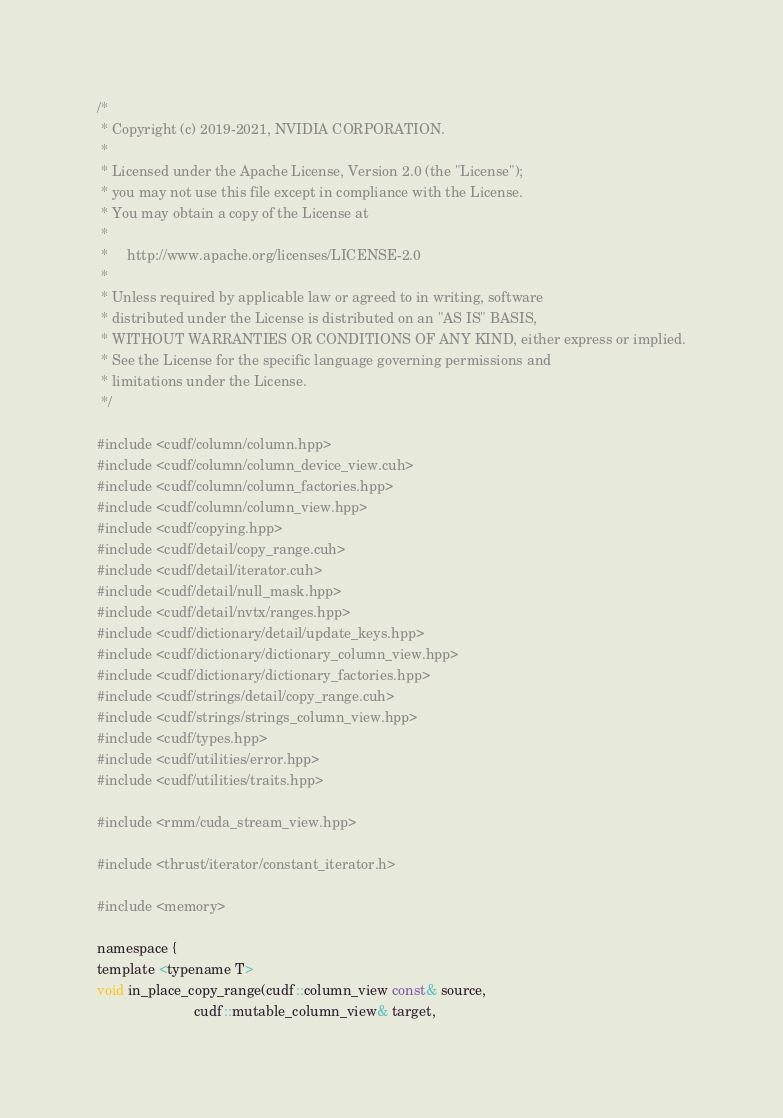Convert code to text. <code><loc_0><loc_0><loc_500><loc_500><_Cuda_>/*
 * Copyright (c) 2019-2021, NVIDIA CORPORATION.
 *
 * Licensed under the Apache License, Version 2.0 (the "License");
 * you may not use this file except in compliance with the License.
 * You may obtain a copy of the License at
 *
 *     http://www.apache.org/licenses/LICENSE-2.0
 *
 * Unless required by applicable law or agreed to in writing, software
 * distributed under the License is distributed on an "AS IS" BASIS,
 * WITHOUT WARRANTIES OR CONDITIONS OF ANY KIND, either express or implied.
 * See the License for the specific language governing permissions and
 * limitations under the License.
 */

#include <cudf/column/column.hpp>
#include <cudf/column/column_device_view.cuh>
#include <cudf/column/column_factories.hpp>
#include <cudf/column/column_view.hpp>
#include <cudf/copying.hpp>
#include <cudf/detail/copy_range.cuh>
#include <cudf/detail/iterator.cuh>
#include <cudf/detail/null_mask.hpp>
#include <cudf/detail/nvtx/ranges.hpp>
#include <cudf/dictionary/detail/update_keys.hpp>
#include <cudf/dictionary/dictionary_column_view.hpp>
#include <cudf/dictionary/dictionary_factories.hpp>
#include <cudf/strings/detail/copy_range.cuh>
#include <cudf/strings/strings_column_view.hpp>
#include <cudf/types.hpp>
#include <cudf/utilities/error.hpp>
#include <cudf/utilities/traits.hpp>

#include <rmm/cuda_stream_view.hpp>

#include <thrust/iterator/constant_iterator.h>

#include <memory>

namespace {
template <typename T>
void in_place_copy_range(cudf::column_view const& source,
                         cudf::mutable_column_view& target,</code> 